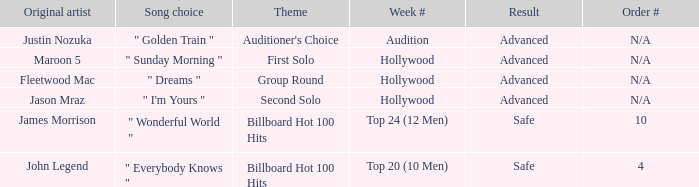What are all of the order # where authentic artist is maroon 5 N/A. 